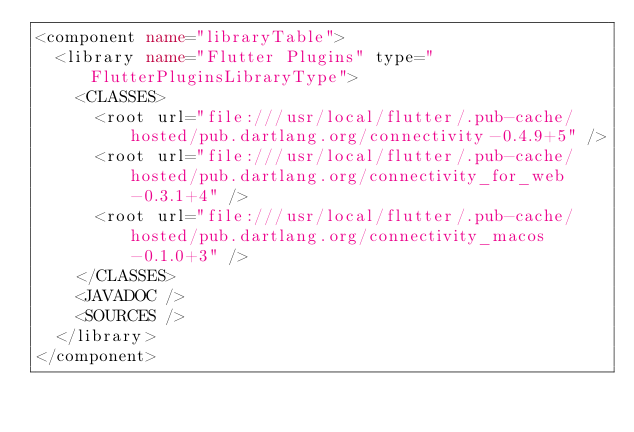Convert code to text. <code><loc_0><loc_0><loc_500><loc_500><_XML_><component name="libraryTable">
  <library name="Flutter Plugins" type="FlutterPluginsLibraryType">
    <CLASSES>
      <root url="file:///usr/local/flutter/.pub-cache/hosted/pub.dartlang.org/connectivity-0.4.9+5" />
      <root url="file:///usr/local/flutter/.pub-cache/hosted/pub.dartlang.org/connectivity_for_web-0.3.1+4" />
      <root url="file:///usr/local/flutter/.pub-cache/hosted/pub.dartlang.org/connectivity_macos-0.1.0+3" />
    </CLASSES>
    <JAVADOC />
    <SOURCES />
  </library>
</component></code> 